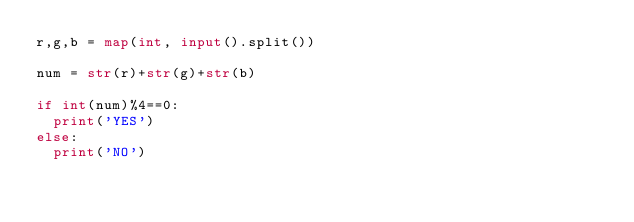Convert code to text. <code><loc_0><loc_0><loc_500><loc_500><_Python_>r,g,b = map(int, input().split())

num = str(r)+str(g)+str(b)

if int(num)%4==0:
  print('YES')
else:
  print('NO')</code> 